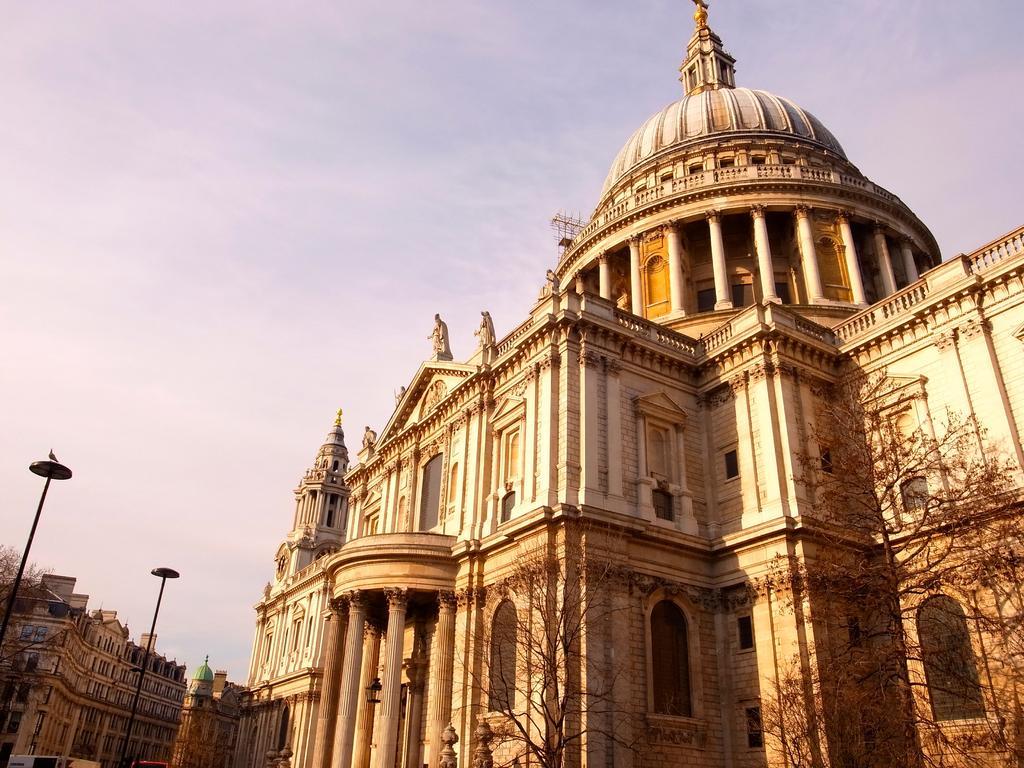How would you summarize this image in a sentence or two? In this picture there are buildings and there are few dried trees in the right corner. 